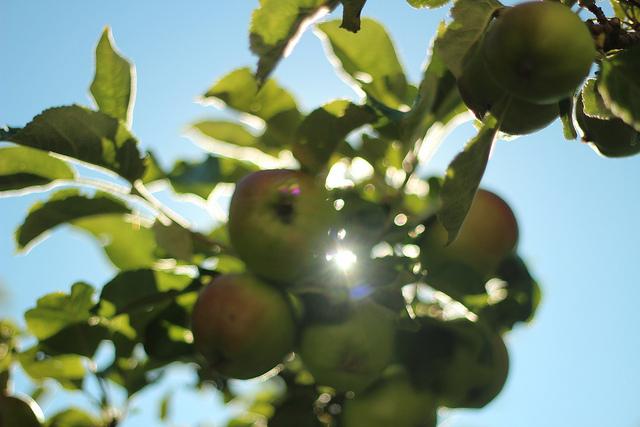Are the apples ripe yet?
Write a very short answer. No. How many apples?
Keep it brief. 9. Is it raining or sunny?
Quick response, please. Sunny. 